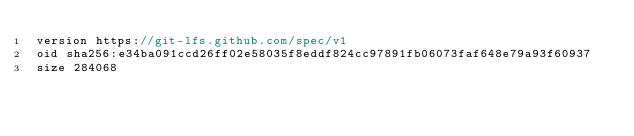<code> <loc_0><loc_0><loc_500><loc_500><_TypeScript_>version https://git-lfs.github.com/spec/v1
oid sha256:e34ba091ccd26ff02e58035f8eddf824cc97891fb06073faf648e79a93f60937
size 284068
</code> 